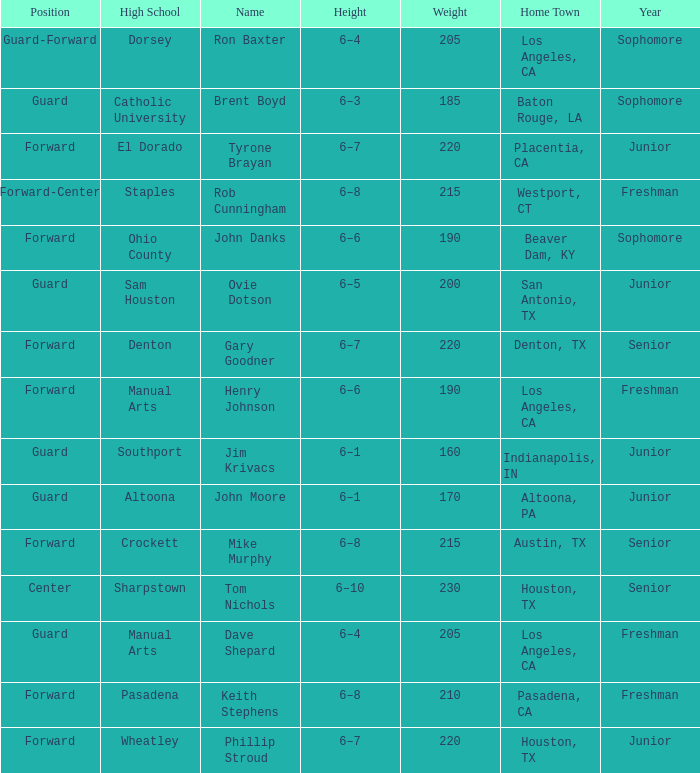What is the Home Town with a Name with rob cunningham? Westport, CT. 